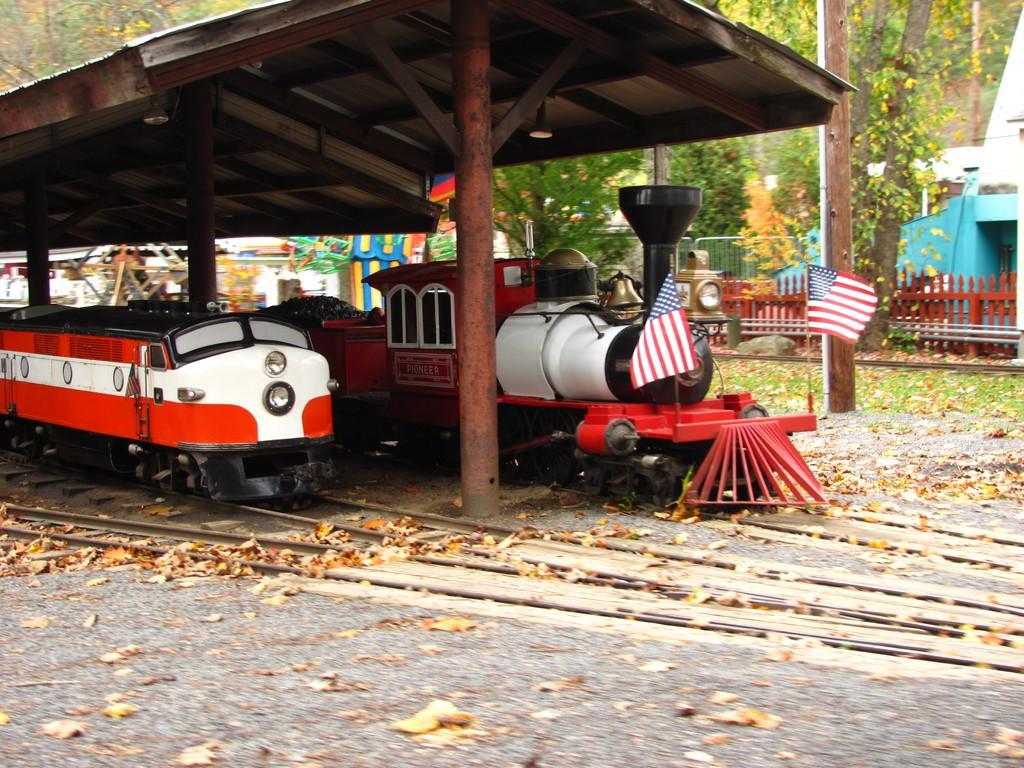Could you give a brief overview of what you see in this image? This is an outside view. On the left side there are two toy trains under the shed. At the bottom, I can see the tracks and dry leaves on the ground. In the background there is a fencing, trees and buildings. 